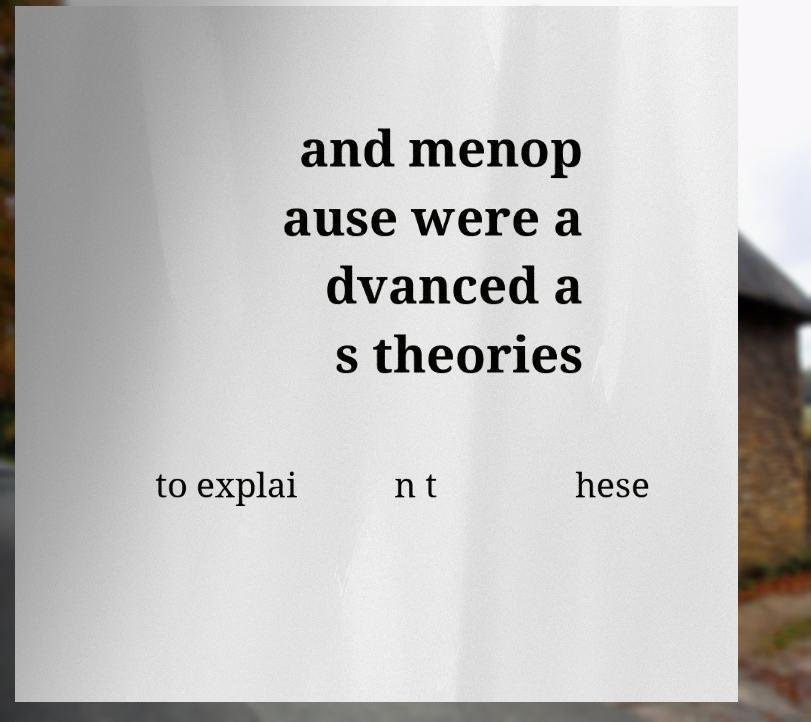Can you accurately transcribe the text from the provided image for me? and menop ause were a dvanced a s theories to explai n t hese 